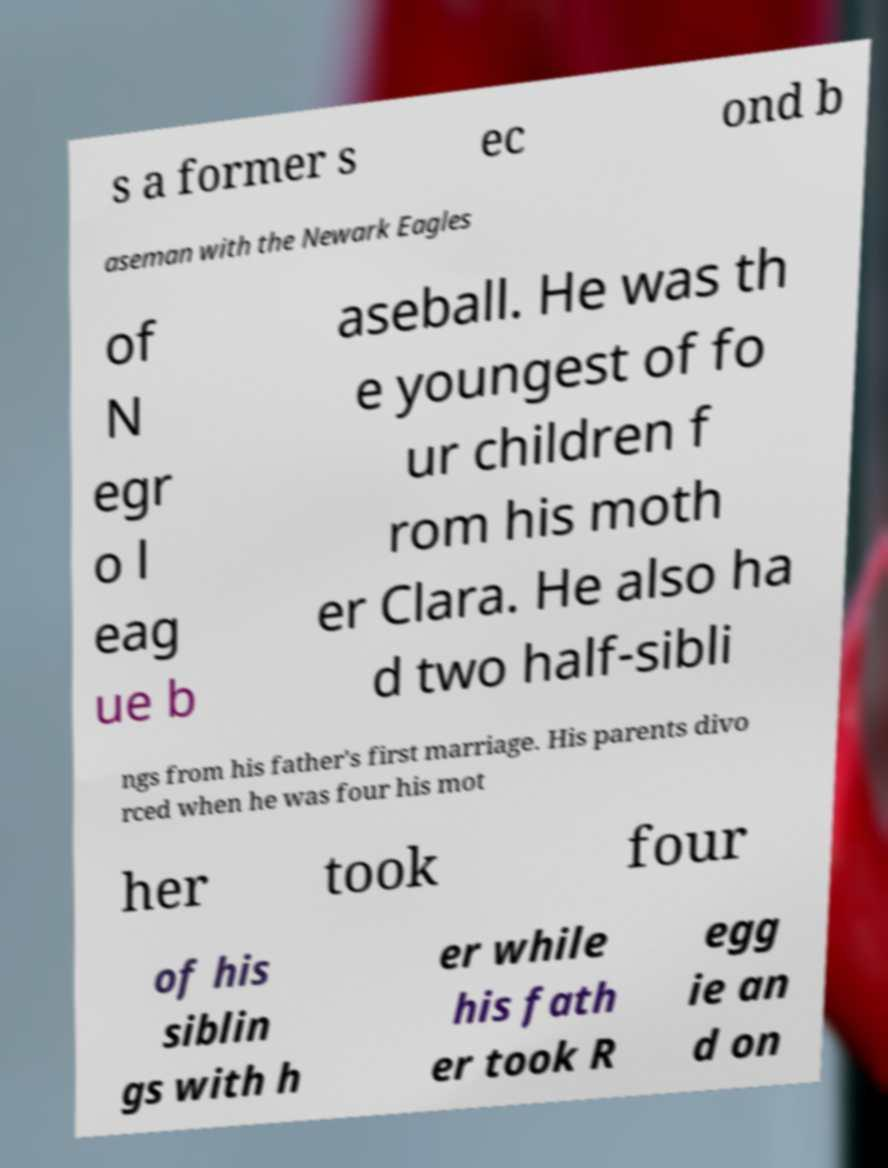Please identify and transcribe the text found in this image. s a former s ec ond b aseman with the Newark Eagles of N egr o l eag ue b aseball. He was th e youngest of fo ur children f rom his moth er Clara. He also ha d two half-sibli ngs from his father's first marriage. His parents divo rced when he was four his mot her took four of his siblin gs with h er while his fath er took R egg ie an d on 